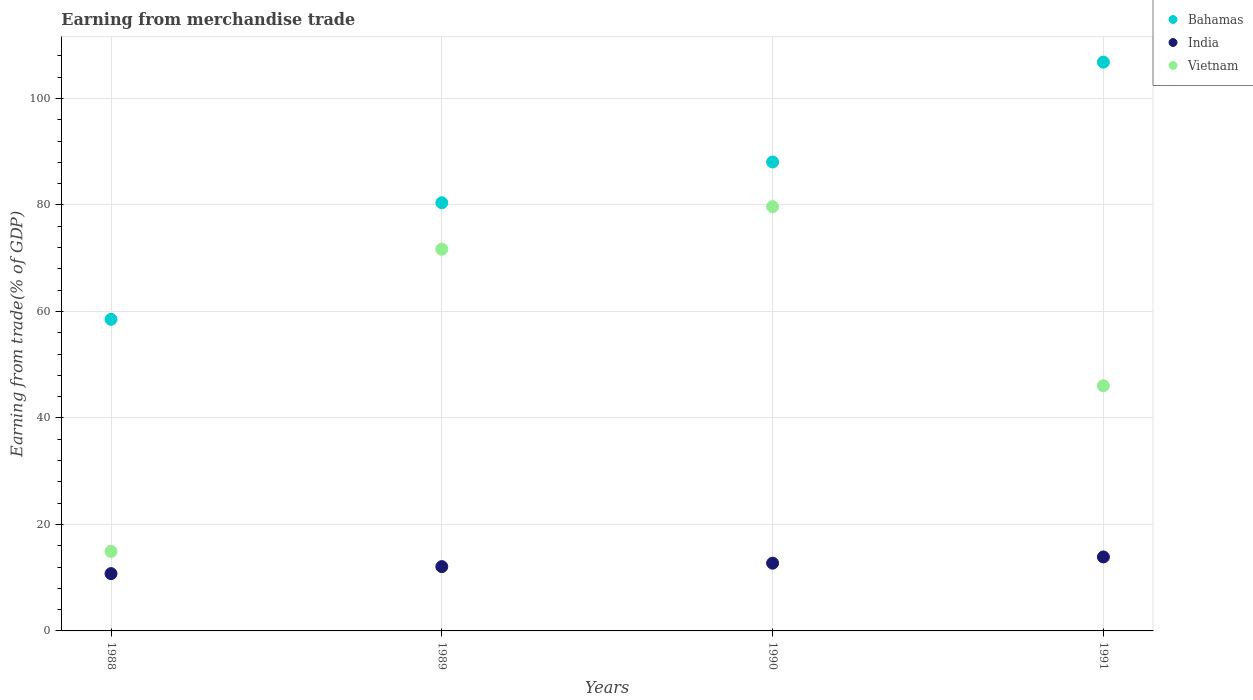Is the number of dotlines equal to the number of legend labels?
Offer a terse response. Yes. What is the earnings from trade in Vietnam in 1989?
Your response must be concise. 71.68. Across all years, what is the maximum earnings from trade in Vietnam?
Ensure brevity in your answer.  79.68. Across all years, what is the minimum earnings from trade in Bahamas?
Keep it short and to the point. 58.52. In which year was the earnings from trade in India maximum?
Your answer should be very brief. 1991. In which year was the earnings from trade in Bahamas minimum?
Make the answer very short. 1988. What is the total earnings from trade in Bahamas in the graph?
Your answer should be very brief. 333.79. What is the difference between the earnings from trade in Bahamas in 1988 and that in 1989?
Provide a succinct answer. -21.89. What is the difference between the earnings from trade in India in 1991 and the earnings from trade in Bahamas in 1989?
Offer a very short reply. -66.52. What is the average earnings from trade in India per year?
Your answer should be very brief. 12.36. In the year 1990, what is the difference between the earnings from trade in Bahamas and earnings from trade in Vietnam?
Your response must be concise. 8.38. In how many years, is the earnings from trade in Vietnam greater than 4 %?
Keep it short and to the point. 4. What is the ratio of the earnings from trade in Bahamas in 1988 to that in 1990?
Keep it short and to the point. 0.66. What is the difference between the highest and the second highest earnings from trade in India?
Provide a succinct answer. 1.17. What is the difference between the highest and the lowest earnings from trade in Bahamas?
Offer a very short reply. 48.29. In how many years, is the earnings from trade in Bahamas greater than the average earnings from trade in Bahamas taken over all years?
Offer a terse response. 2. Is it the case that in every year, the sum of the earnings from trade in Vietnam and earnings from trade in India  is greater than the earnings from trade in Bahamas?
Your response must be concise. No. Does the earnings from trade in Bahamas monotonically increase over the years?
Provide a short and direct response. Yes. Is the earnings from trade in Bahamas strictly greater than the earnings from trade in India over the years?
Your answer should be very brief. Yes. Is the earnings from trade in Bahamas strictly less than the earnings from trade in Vietnam over the years?
Ensure brevity in your answer.  No. How many years are there in the graph?
Make the answer very short. 4. What is the difference between two consecutive major ticks on the Y-axis?
Provide a short and direct response. 20. Are the values on the major ticks of Y-axis written in scientific E-notation?
Offer a very short reply. No. Does the graph contain grids?
Make the answer very short. Yes. Where does the legend appear in the graph?
Keep it short and to the point. Top right. How are the legend labels stacked?
Give a very brief answer. Vertical. What is the title of the graph?
Your answer should be very brief. Earning from merchandise trade. What is the label or title of the X-axis?
Offer a very short reply. Years. What is the label or title of the Y-axis?
Ensure brevity in your answer.  Earning from trade(% of GDP). What is the Earning from trade(% of GDP) of Bahamas in 1988?
Provide a succinct answer. 58.52. What is the Earning from trade(% of GDP) in India in 1988?
Ensure brevity in your answer.  10.76. What is the Earning from trade(% of GDP) in Vietnam in 1988?
Your answer should be very brief. 14.92. What is the Earning from trade(% of GDP) of Bahamas in 1989?
Offer a very short reply. 80.4. What is the Earning from trade(% of GDP) of India in 1989?
Make the answer very short. 12.08. What is the Earning from trade(% of GDP) of Vietnam in 1989?
Your answer should be compact. 71.68. What is the Earning from trade(% of GDP) in Bahamas in 1990?
Make the answer very short. 88.06. What is the Earning from trade(% of GDP) of India in 1990?
Make the answer very short. 12.72. What is the Earning from trade(% of GDP) in Vietnam in 1990?
Provide a short and direct response. 79.68. What is the Earning from trade(% of GDP) in Bahamas in 1991?
Provide a succinct answer. 106.81. What is the Earning from trade(% of GDP) of India in 1991?
Ensure brevity in your answer.  13.89. What is the Earning from trade(% of GDP) of Vietnam in 1991?
Your response must be concise. 46.03. Across all years, what is the maximum Earning from trade(% of GDP) in Bahamas?
Offer a terse response. 106.81. Across all years, what is the maximum Earning from trade(% of GDP) of India?
Provide a succinct answer. 13.89. Across all years, what is the maximum Earning from trade(% of GDP) of Vietnam?
Offer a terse response. 79.68. Across all years, what is the minimum Earning from trade(% of GDP) in Bahamas?
Provide a short and direct response. 58.52. Across all years, what is the minimum Earning from trade(% of GDP) of India?
Offer a terse response. 10.76. Across all years, what is the minimum Earning from trade(% of GDP) of Vietnam?
Ensure brevity in your answer.  14.92. What is the total Earning from trade(% of GDP) of Bahamas in the graph?
Your answer should be compact. 333.79. What is the total Earning from trade(% of GDP) of India in the graph?
Give a very brief answer. 49.45. What is the total Earning from trade(% of GDP) of Vietnam in the graph?
Keep it short and to the point. 212.31. What is the difference between the Earning from trade(% of GDP) in Bahamas in 1988 and that in 1989?
Give a very brief answer. -21.89. What is the difference between the Earning from trade(% of GDP) in India in 1988 and that in 1989?
Provide a short and direct response. -1.32. What is the difference between the Earning from trade(% of GDP) of Vietnam in 1988 and that in 1989?
Make the answer very short. -56.76. What is the difference between the Earning from trade(% of GDP) of Bahamas in 1988 and that in 1990?
Your response must be concise. -29.54. What is the difference between the Earning from trade(% of GDP) of India in 1988 and that in 1990?
Offer a very short reply. -1.96. What is the difference between the Earning from trade(% of GDP) in Vietnam in 1988 and that in 1990?
Keep it short and to the point. -64.75. What is the difference between the Earning from trade(% of GDP) of Bahamas in 1988 and that in 1991?
Make the answer very short. -48.29. What is the difference between the Earning from trade(% of GDP) of India in 1988 and that in 1991?
Offer a terse response. -3.13. What is the difference between the Earning from trade(% of GDP) in Vietnam in 1988 and that in 1991?
Keep it short and to the point. -31.11. What is the difference between the Earning from trade(% of GDP) in Bahamas in 1989 and that in 1990?
Provide a succinct answer. -7.66. What is the difference between the Earning from trade(% of GDP) of India in 1989 and that in 1990?
Your response must be concise. -0.64. What is the difference between the Earning from trade(% of GDP) in Vietnam in 1989 and that in 1990?
Offer a terse response. -8. What is the difference between the Earning from trade(% of GDP) of Bahamas in 1989 and that in 1991?
Your answer should be very brief. -26.4. What is the difference between the Earning from trade(% of GDP) of India in 1989 and that in 1991?
Your answer should be compact. -1.81. What is the difference between the Earning from trade(% of GDP) in Vietnam in 1989 and that in 1991?
Provide a succinct answer. 25.65. What is the difference between the Earning from trade(% of GDP) of Bahamas in 1990 and that in 1991?
Keep it short and to the point. -18.75. What is the difference between the Earning from trade(% of GDP) of India in 1990 and that in 1991?
Give a very brief answer. -1.17. What is the difference between the Earning from trade(% of GDP) of Vietnam in 1990 and that in 1991?
Offer a terse response. 33.64. What is the difference between the Earning from trade(% of GDP) in Bahamas in 1988 and the Earning from trade(% of GDP) in India in 1989?
Provide a short and direct response. 46.44. What is the difference between the Earning from trade(% of GDP) in Bahamas in 1988 and the Earning from trade(% of GDP) in Vietnam in 1989?
Give a very brief answer. -13.16. What is the difference between the Earning from trade(% of GDP) in India in 1988 and the Earning from trade(% of GDP) in Vietnam in 1989?
Provide a succinct answer. -60.92. What is the difference between the Earning from trade(% of GDP) in Bahamas in 1988 and the Earning from trade(% of GDP) in India in 1990?
Give a very brief answer. 45.8. What is the difference between the Earning from trade(% of GDP) in Bahamas in 1988 and the Earning from trade(% of GDP) in Vietnam in 1990?
Give a very brief answer. -21.16. What is the difference between the Earning from trade(% of GDP) of India in 1988 and the Earning from trade(% of GDP) of Vietnam in 1990?
Give a very brief answer. -68.92. What is the difference between the Earning from trade(% of GDP) in Bahamas in 1988 and the Earning from trade(% of GDP) in India in 1991?
Your response must be concise. 44.63. What is the difference between the Earning from trade(% of GDP) in Bahamas in 1988 and the Earning from trade(% of GDP) in Vietnam in 1991?
Provide a succinct answer. 12.49. What is the difference between the Earning from trade(% of GDP) of India in 1988 and the Earning from trade(% of GDP) of Vietnam in 1991?
Keep it short and to the point. -35.27. What is the difference between the Earning from trade(% of GDP) of Bahamas in 1989 and the Earning from trade(% of GDP) of India in 1990?
Offer a terse response. 67.68. What is the difference between the Earning from trade(% of GDP) in Bahamas in 1989 and the Earning from trade(% of GDP) in Vietnam in 1990?
Keep it short and to the point. 0.73. What is the difference between the Earning from trade(% of GDP) in India in 1989 and the Earning from trade(% of GDP) in Vietnam in 1990?
Ensure brevity in your answer.  -67.6. What is the difference between the Earning from trade(% of GDP) in Bahamas in 1989 and the Earning from trade(% of GDP) in India in 1991?
Your answer should be very brief. 66.52. What is the difference between the Earning from trade(% of GDP) in Bahamas in 1989 and the Earning from trade(% of GDP) in Vietnam in 1991?
Your response must be concise. 34.37. What is the difference between the Earning from trade(% of GDP) in India in 1989 and the Earning from trade(% of GDP) in Vietnam in 1991?
Provide a short and direct response. -33.95. What is the difference between the Earning from trade(% of GDP) of Bahamas in 1990 and the Earning from trade(% of GDP) of India in 1991?
Give a very brief answer. 74.17. What is the difference between the Earning from trade(% of GDP) in Bahamas in 1990 and the Earning from trade(% of GDP) in Vietnam in 1991?
Ensure brevity in your answer.  42.03. What is the difference between the Earning from trade(% of GDP) of India in 1990 and the Earning from trade(% of GDP) of Vietnam in 1991?
Make the answer very short. -33.31. What is the average Earning from trade(% of GDP) in Bahamas per year?
Your answer should be very brief. 83.45. What is the average Earning from trade(% of GDP) of India per year?
Give a very brief answer. 12.36. What is the average Earning from trade(% of GDP) in Vietnam per year?
Offer a very short reply. 53.08. In the year 1988, what is the difference between the Earning from trade(% of GDP) in Bahamas and Earning from trade(% of GDP) in India?
Your response must be concise. 47.76. In the year 1988, what is the difference between the Earning from trade(% of GDP) of Bahamas and Earning from trade(% of GDP) of Vietnam?
Your response must be concise. 43.6. In the year 1988, what is the difference between the Earning from trade(% of GDP) of India and Earning from trade(% of GDP) of Vietnam?
Give a very brief answer. -4.16. In the year 1989, what is the difference between the Earning from trade(% of GDP) of Bahamas and Earning from trade(% of GDP) of India?
Your answer should be very brief. 68.33. In the year 1989, what is the difference between the Earning from trade(% of GDP) of Bahamas and Earning from trade(% of GDP) of Vietnam?
Keep it short and to the point. 8.73. In the year 1989, what is the difference between the Earning from trade(% of GDP) in India and Earning from trade(% of GDP) in Vietnam?
Provide a succinct answer. -59.6. In the year 1990, what is the difference between the Earning from trade(% of GDP) of Bahamas and Earning from trade(% of GDP) of India?
Ensure brevity in your answer.  75.34. In the year 1990, what is the difference between the Earning from trade(% of GDP) of Bahamas and Earning from trade(% of GDP) of Vietnam?
Ensure brevity in your answer.  8.38. In the year 1990, what is the difference between the Earning from trade(% of GDP) of India and Earning from trade(% of GDP) of Vietnam?
Your response must be concise. -66.95. In the year 1991, what is the difference between the Earning from trade(% of GDP) in Bahamas and Earning from trade(% of GDP) in India?
Provide a succinct answer. 92.92. In the year 1991, what is the difference between the Earning from trade(% of GDP) of Bahamas and Earning from trade(% of GDP) of Vietnam?
Provide a succinct answer. 60.78. In the year 1991, what is the difference between the Earning from trade(% of GDP) in India and Earning from trade(% of GDP) in Vietnam?
Provide a succinct answer. -32.14. What is the ratio of the Earning from trade(% of GDP) of Bahamas in 1988 to that in 1989?
Offer a terse response. 0.73. What is the ratio of the Earning from trade(% of GDP) of India in 1988 to that in 1989?
Provide a short and direct response. 0.89. What is the ratio of the Earning from trade(% of GDP) in Vietnam in 1988 to that in 1989?
Provide a succinct answer. 0.21. What is the ratio of the Earning from trade(% of GDP) of Bahamas in 1988 to that in 1990?
Provide a short and direct response. 0.66. What is the ratio of the Earning from trade(% of GDP) in India in 1988 to that in 1990?
Ensure brevity in your answer.  0.85. What is the ratio of the Earning from trade(% of GDP) of Vietnam in 1988 to that in 1990?
Your response must be concise. 0.19. What is the ratio of the Earning from trade(% of GDP) of Bahamas in 1988 to that in 1991?
Your answer should be compact. 0.55. What is the ratio of the Earning from trade(% of GDP) in India in 1988 to that in 1991?
Ensure brevity in your answer.  0.77. What is the ratio of the Earning from trade(% of GDP) in Vietnam in 1988 to that in 1991?
Your response must be concise. 0.32. What is the ratio of the Earning from trade(% of GDP) in Bahamas in 1989 to that in 1990?
Keep it short and to the point. 0.91. What is the ratio of the Earning from trade(% of GDP) in India in 1989 to that in 1990?
Your answer should be compact. 0.95. What is the ratio of the Earning from trade(% of GDP) of Vietnam in 1989 to that in 1990?
Give a very brief answer. 0.9. What is the ratio of the Earning from trade(% of GDP) in Bahamas in 1989 to that in 1991?
Give a very brief answer. 0.75. What is the ratio of the Earning from trade(% of GDP) in India in 1989 to that in 1991?
Provide a short and direct response. 0.87. What is the ratio of the Earning from trade(% of GDP) of Vietnam in 1989 to that in 1991?
Give a very brief answer. 1.56. What is the ratio of the Earning from trade(% of GDP) of Bahamas in 1990 to that in 1991?
Offer a terse response. 0.82. What is the ratio of the Earning from trade(% of GDP) in India in 1990 to that in 1991?
Ensure brevity in your answer.  0.92. What is the ratio of the Earning from trade(% of GDP) in Vietnam in 1990 to that in 1991?
Provide a succinct answer. 1.73. What is the difference between the highest and the second highest Earning from trade(% of GDP) in Bahamas?
Provide a short and direct response. 18.75. What is the difference between the highest and the second highest Earning from trade(% of GDP) of India?
Make the answer very short. 1.17. What is the difference between the highest and the second highest Earning from trade(% of GDP) in Vietnam?
Give a very brief answer. 8. What is the difference between the highest and the lowest Earning from trade(% of GDP) in Bahamas?
Your answer should be compact. 48.29. What is the difference between the highest and the lowest Earning from trade(% of GDP) in India?
Your response must be concise. 3.13. What is the difference between the highest and the lowest Earning from trade(% of GDP) in Vietnam?
Keep it short and to the point. 64.75. 